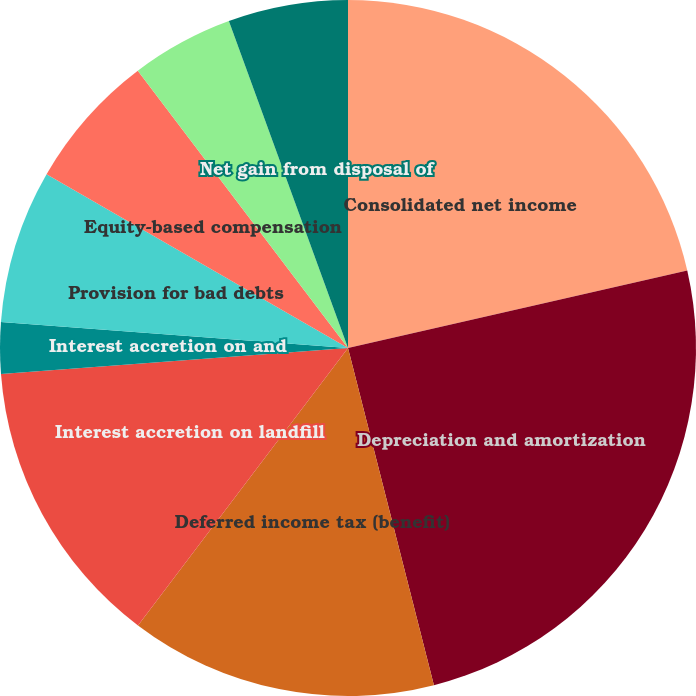Convert chart. <chart><loc_0><loc_0><loc_500><loc_500><pie_chart><fcel>Consolidated net income<fcel>Depreciation and amortization<fcel>Deferred income tax (benefit)<fcel>Interest accretion on landfill<fcel>Interest accretion on and<fcel>Provision for bad debts<fcel>Equity-based compensation<fcel>Equity in net losses of<fcel>Net gain from disposal of<fcel>Effect of (income) expense<nl><fcel>21.42%<fcel>24.6%<fcel>14.28%<fcel>13.49%<fcel>2.38%<fcel>7.14%<fcel>6.35%<fcel>4.76%<fcel>5.56%<fcel>0.0%<nl></chart> 